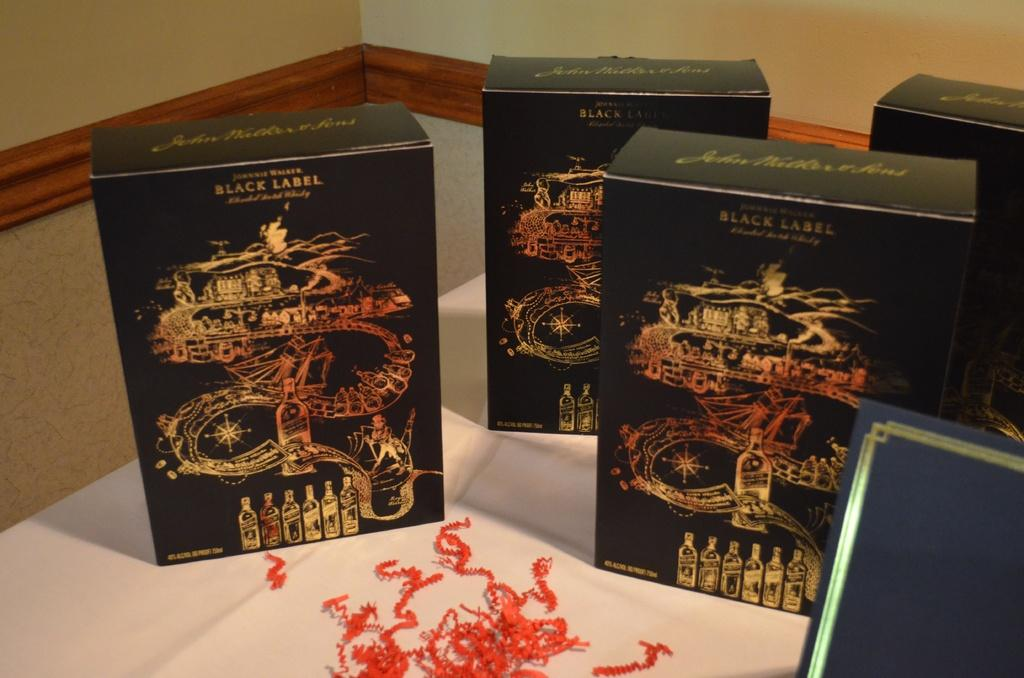<image>
Share a concise interpretation of the image provided. several black boxes for Black Label on a table 